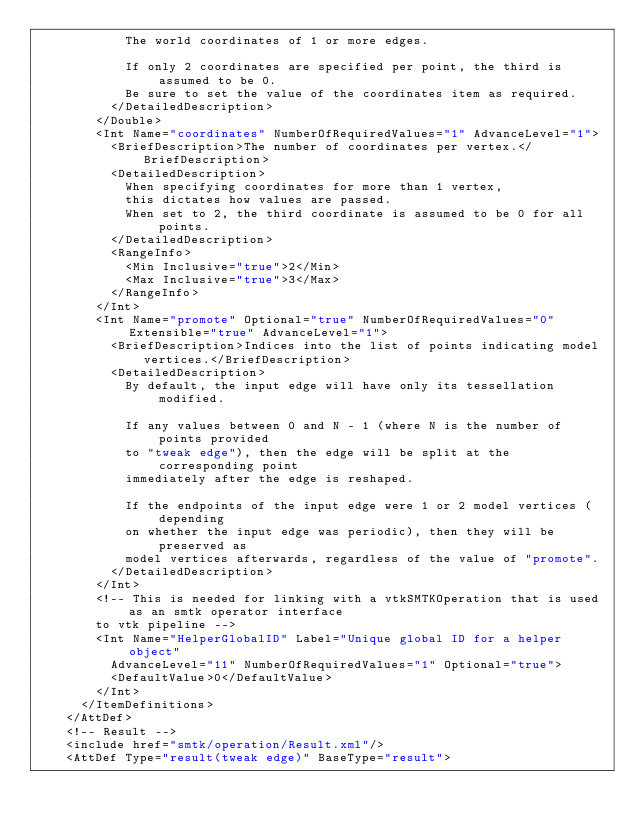Convert code to text. <code><loc_0><loc_0><loc_500><loc_500><_Scala_>            The world coordinates of 1 or more edges.

            If only 2 coordinates are specified per point, the third is assumed to be 0.
            Be sure to set the value of the coordinates item as required.
          </DetailedDescription>
        </Double>
        <Int Name="coordinates" NumberOfRequiredValues="1" AdvanceLevel="1">
          <BriefDescription>The number of coordinates per vertex.</BriefDescription>
          <DetailedDescription>
            When specifying coordinates for more than 1 vertex,
            this dictates how values are passed.
            When set to 2, the third coordinate is assumed to be 0 for all points.
          </DetailedDescription>
          <RangeInfo>
            <Min Inclusive="true">2</Min>
            <Max Inclusive="true">3</Max>
          </RangeInfo>
        </Int>
        <Int Name="promote" Optional="true" NumberOfRequiredValues="0" Extensible="true" AdvanceLevel="1">
          <BriefDescription>Indices into the list of points indicating model vertices.</BriefDescription>
          <DetailedDescription>
            By default, the input edge will have only its tessellation modified.

            If any values between 0 and N - 1 (where N is the number of points provided
            to "tweak edge"), then the edge will be split at the corresponding point
            immediately after the edge is reshaped.

            If the endpoints of the input edge were 1 or 2 model vertices (depending
            on whether the input edge was periodic), then they will be preserved as
            model vertices afterwards, regardless of the value of "promote".
          </DetailedDescription>
        </Int>
        <!-- This is needed for linking with a vtkSMTKOperation that is used as an smtk operator interface
        to vtk pipeline -->
        <Int Name="HelperGlobalID" Label="Unique global ID for a helper object"
          AdvanceLevel="11" NumberOfRequiredValues="1" Optional="true">
          <DefaultValue>0</DefaultValue>
        </Int>
      </ItemDefinitions>
    </AttDef>
    <!-- Result -->
    <include href="smtk/operation/Result.xml"/>
    <AttDef Type="result(tweak edge)" BaseType="result"></code> 